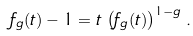Convert formula to latex. <formula><loc_0><loc_0><loc_500><loc_500>f _ { g } ( t ) - 1 = t \, \left ( f _ { g } ( t ) \right ) ^ { 1 - g } \, .</formula> 